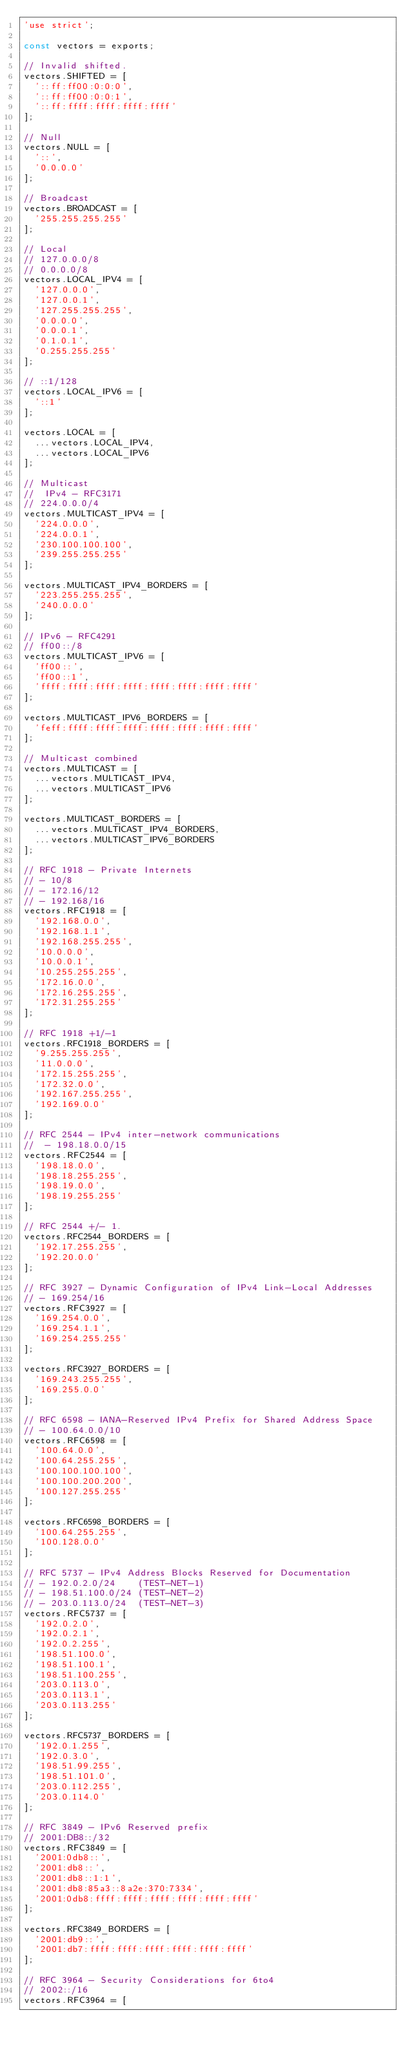Convert code to text. <code><loc_0><loc_0><loc_500><loc_500><_JavaScript_>'use strict';

const vectors = exports;

// Invalid shifted.
vectors.SHIFTED = [
  '::ff:ff00:0:0:0',
  '::ff:ff00:0:0:1',
  '::ff:ffff:ffff:ffff:ffff'
];

// Null
vectors.NULL = [
  '::',
  '0.0.0.0'
];

// Broadcast
vectors.BROADCAST = [
  '255.255.255.255'
];

// Local
// 127.0.0.0/8
// 0.0.0.0/8
vectors.LOCAL_IPV4 = [
  '127.0.0.0',
  '127.0.0.1',
  '127.255.255.255',
  '0.0.0.0',
  '0.0.0.1',
  '0.1.0.1',
  '0.255.255.255'
];

// ::1/128
vectors.LOCAL_IPV6 = [
  '::1'
];

vectors.LOCAL = [
  ...vectors.LOCAL_IPV4,
  ...vectors.LOCAL_IPV6
];

// Multicast
//  IPv4 - RFC3171
// 224.0.0.0/4
vectors.MULTICAST_IPV4 = [
  '224.0.0.0',
  '224.0.0.1',
  '230.100.100.100',
  '239.255.255.255'
];

vectors.MULTICAST_IPV4_BORDERS = [
  '223.255.255.255',
  '240.0.0.0'
];

// IPv6 - RFC4291
// ff00::/8
vectors.MULTICAST_IPV6 = [
  'ff00::',
  'ff00::1',
  'ffff:ffff:ffff:ffff:ffff:ffff:ffff:ffff'
];

vectors.MULTICAST_IPV6_BORDERS = [
  'feff:ffff:ffff:ffff:ffff:ffff:ffff:ffff'
];

// Multicast combined
vectors.MULTICAST = [
  ...vectors.MULTICAST_IPV4,
  ...vectors.MULTICAST_IPV6
];

vectors.MULTICAST_BORDERS = [
  ...vectors.MULTICAST_IPV4_BORDERS,
  ...vectors.MULTICAST_IPV6_BORDERS
];

// RFC 1918 - Private Internets
// - 10/8
// - 172.16/12
// - 192.168/16
vectors.RFC1918 = [
  '192.168.0.0',
  '192.168.1.1',
  '192.168.255.255',
  '10.0.0.0',
  '10.0.0.1',
  '10.255.255.255',
  '172.16.0.0',
  '172.16.255.255',
  '172.31.255.255'
];

// RFC 1918 +1/-1
vectors.RFC1918_BORDERS = [
  '9.255.255.255',
  '11.0.0.0',
  '172.15.255.255',
  '172.32.0.0',
  '192.167.255.255',
  '192.169.0.0'
];

// RFC 2544 - IPv4 inter-network communications
//  - 198.18.0.0/15
vectors.RFC2544 = [
  '198.18.0.0',
  '198.18.255.255',
  '198.19.0.0',
  '198.19.255.255'
];

// RFC 2544 +/- 1.
vectors.RFC2544_BORDERS = [
  '192.17.255.255',
  '192.20.0.0'
];

// RFC 3927 - Dynamic Configuration of IPv4 Link-Local Addresses
// - 169.254/16
vectors.RFC3927 = [
  '169.254.0.0',
  '169.254.1.1',
  '169.254.255.255'
];

vectors.RFC3927_BORDERS = [
  '169.243.255.255',
  '169.255.0.0'
];

// RFC 6598 - IANA-Reserved IPv4 Prefix for Shared Address Space
// - 100.64.0.0/10
vectors.RFC6598 = [
  '100.64.0.0',
  '100.64.255.255',
  '100.100.100.100',
  '100.100.200.200',
  '100.127.255.255'
];

vectors.RFC6598_BORDERS = [
  '100.64.255.255',
  '100.128.0.0'
];

// RFC 5737 - IPv4 Address Blocks Reserved for Documentation
// - 192.0.2.0/24    (TEST-NET-1)
// - 198.51.100.0/24 (TEST-NET-2)
// - 203.0.113.0/24  (TEST-NET-3)
vectors.RFC5737 = [
  '192.0.2.0',
  '192.0.2.1',
  '192.0.2.255',
  '198.51.100.0',
  '198.51.100.1',
  '198.51.100.255',
  '203.0.113.0',
  '203.0.113.1',
  '203.0.113.255'
];

vectors.RFC5737_BORDERS = [
  '192.0.1.255',
  '192.0.3.0',
  '198.51.99.255',
  '198.51.101.0',
  '203.0.112.255',
  '203.0.114.0'
];

// RFC 3849 - IPv6 Reserved prefix
// 2001:DB8::/32
vectors.RFC3849 = [
  '2001:0db8::',
  '2001:db8::',
  '2001:db8::1:1',
  '2001:db8:85a3::8a2e:370:7334',
  '2001:0db8:ffff:ffff:ffff:ffff:ffff:ffff'
];

vectors.RFC3849_BORDERS = [
  '2001:db9::',
  '2001:db7:ffff:ffff:ffff:ffff:ffff:ffff'
];

// RFC 3964 - Security Considerations for 6to4
// 2002::/16
vectors.RFC3964 = [</code> 